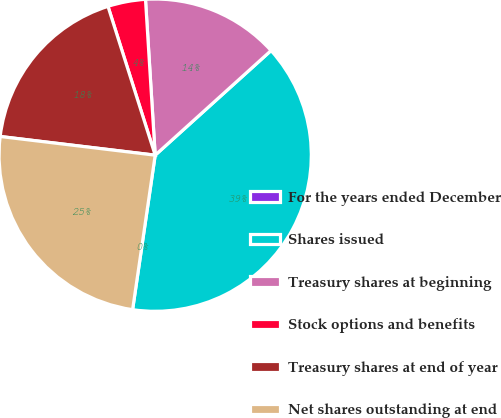Convert chart. <chart><loc_0><loc_0><loc_500><loc_500><pie_chart><fcel>For the years ended December<fcel>Shares issued<fcel>Treasury shares at beginning<fcel>Stock options and benefits<fcel>Treasury shares at end of year<fcel>Net shares outstanding at end<nl><fcel>0.0%<fcel>39.0%<fcel>14.3%<fcel>3.9%<fcel>18.2%<fcel>24.6%<nl></chart> 